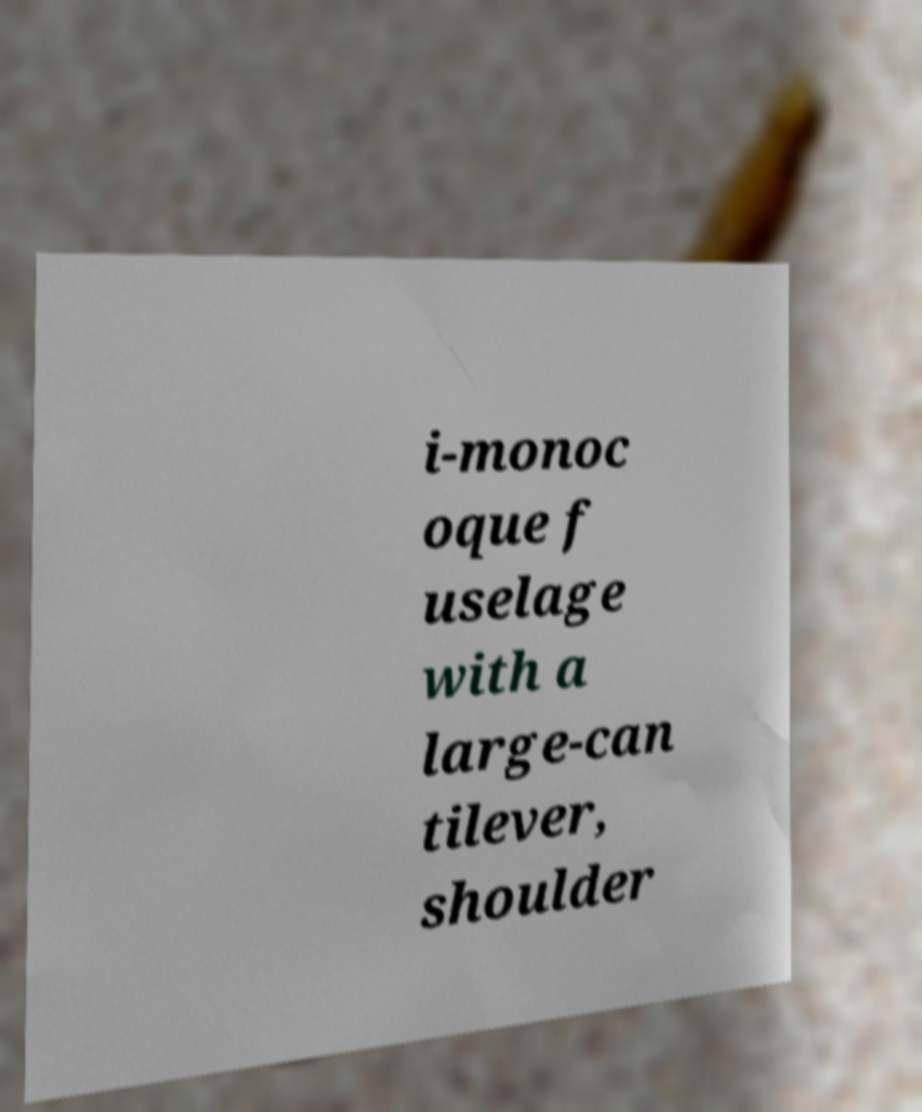Could you assist in decoding the text presented in this image and type it out clearly? i-monoc oque f uselage with a large-can tilever, shoulder 